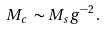<formula> <loc_0><loc_0><loc_500><loc_500>M _ { c } \, \sim M _ { s } g ^ { - 2 } \, .</formula> 